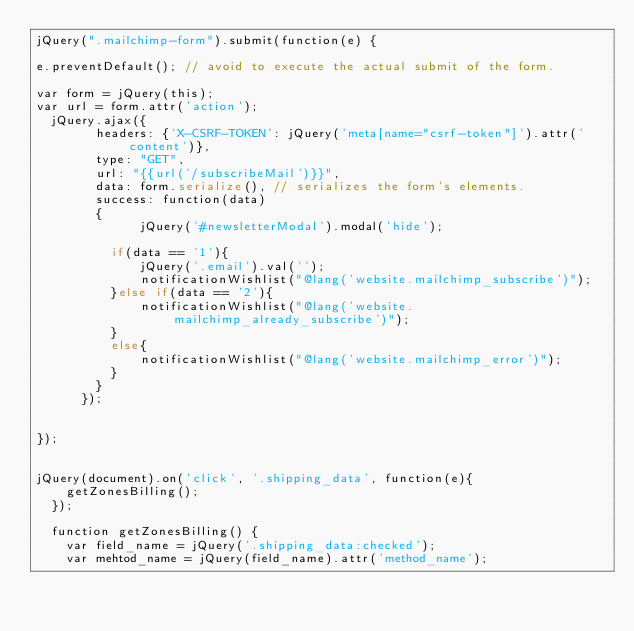Convert code to text. <code><loc_0><loc_0><loc_500><loc_500><_PHP_>jQuery(".mailchimp-form").submit(function(e) {

e.preventDefault(); // avoid to execute the actual submit of the form.

var form = jQuery(this);
var url = form.attr('action');
  jQuery.ajax({
        headers: {'X-CSRF-TOKEN': jQuery('meta[name="csrf-token"]').attr('content')},
        type: "GET",
        url: "{{url('/subscribeMail')}}",
        data: form.serialize(), // serializes the form's elements.
        success: function(data)
        {
			  jQuery('#newsletterModal').modal('hide');
			
          if(data == '1'){
              jQuery('.email').val('');
              notificationWishlist("@lang('website.mailchimp_subscribe')");
          }else if(data == '2'){
              notificationWishlist("@lang('website.mailchimp_already_subscribe')");
          }
          else{
              notificationWishlist("@lang('website.mailchimp_error')");
          }
        }
      });


});


jQuery(document).on('click', '.shipping_data', function(e){
    getZonesBilling();
  });
  
  function getZonesBilling() {
    var field_name = jQuery('.shipping_data:checked');
    var mehtod_name = jQuery(field_name).attr('method_name');</code> 